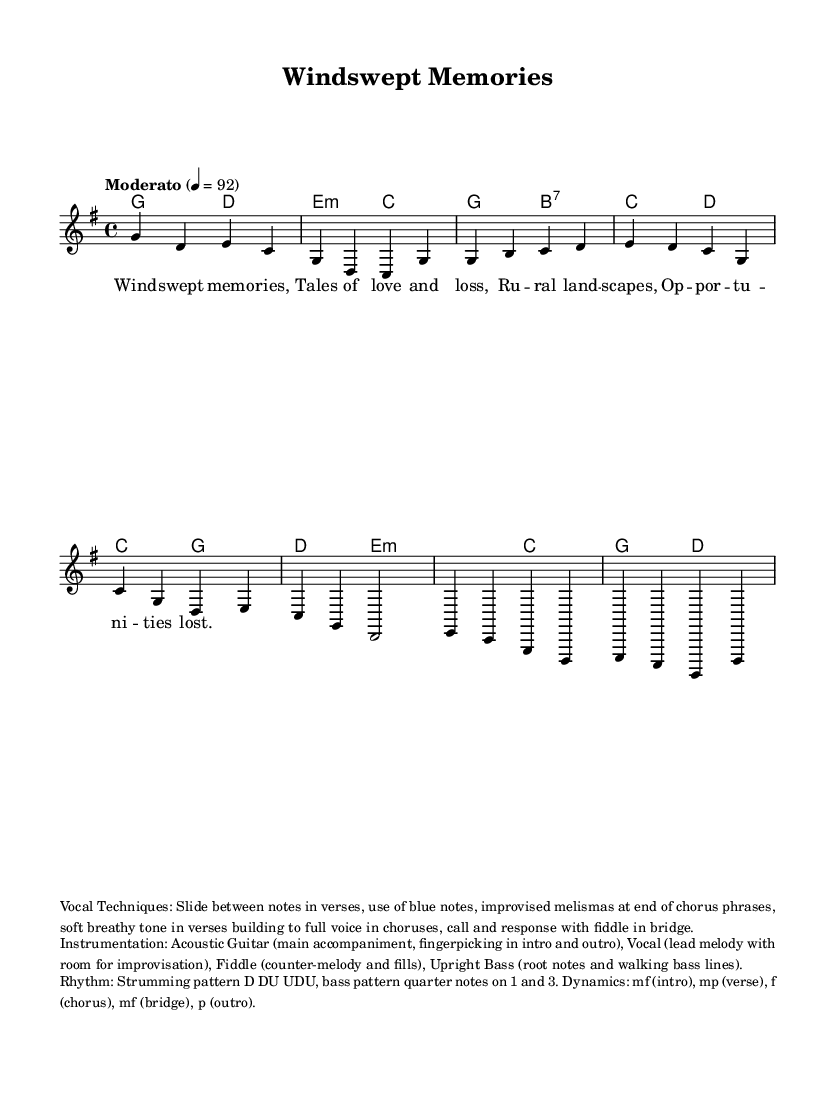What is the key signature of this music? The key signature is G major, which has one sharp (F#). This is evident as the score indicates the key at the beginning with a 'G' and a sharp symbol, specifically chosen for the piece.
Answer: G major What is the time signature of the piece? The time signature is 4/4, which is indicated at the start of the music. This means there are four beats in each measure and the quarter note gets one beat.
Answer: 4/4 What is the tempo marking for the piece? The tempo marking is "Moderato" at a speed of 92 beats per minute. This is shown at the beginning of the score, providing a guideline for the expected speed of the performance.
Answer: Moderato, 92 Which vocal techniques are suggested for this piece? The suggested vocal techniques include sliding between notes in verses, use of blue notes, and improvised melismas. These techniques are outlined in the markup section, emphasizing the expressive qualities unique to country vocal styles.
Answer: Slide, blue notes, melismas What is the suggested strumming pattern for the guitar? The strumming pattern is D DU UDU, which is noted in the markup section discussing rhythm. It lays out the sequence of down and up strums vital for performing the acoustic guitar part authentically in country music.
Answer: D DU UDU What dynamics are indicated for the chorus section? The dynamics for the chorus section are marked as f, which indicates a forte volume, suggesting the singer should project their voice more prominently during this part. This is essential for building intensity in the performance.
Answer: f What is the instrumentation used in this piece? The instrumentation includes acoustic guitar, lead vocal (with room for improvisation), fiddle, and upright bass. This is detailed in the markup section about instrumentation, structuring the overall sound of the performance.
Answer: Acoustic guitar, vocal, fiddle, upright bass 